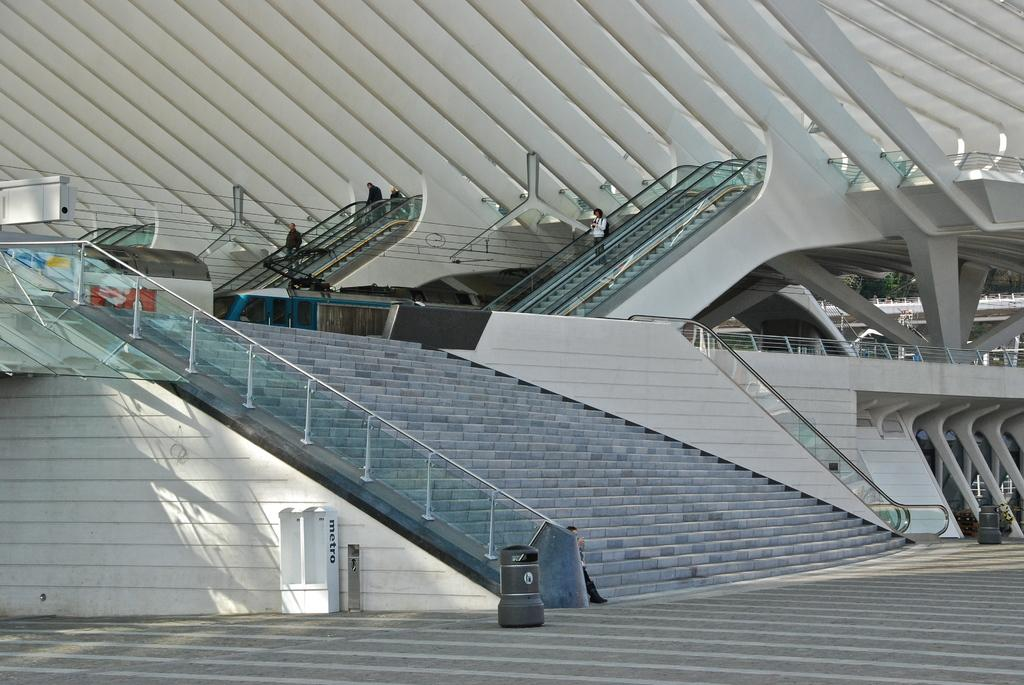What type of structure is present in the image? There is a building in the image. What is the purpose of the barrier in the image? There is a fence in the image, which serves as a barrier or boundary. Are there any architectural features in the image? Yes, there are stairs in the image. Can you describe the people in the image? There are people present in the image, but their specific actions or characteristics are not mentioned in the provided facts. What type of plantation is visible in the image? There is no plantation present in the image. What time of day is depicted in the image? The provided facts do not mention the time of day, so it cannot be determined from the image. 